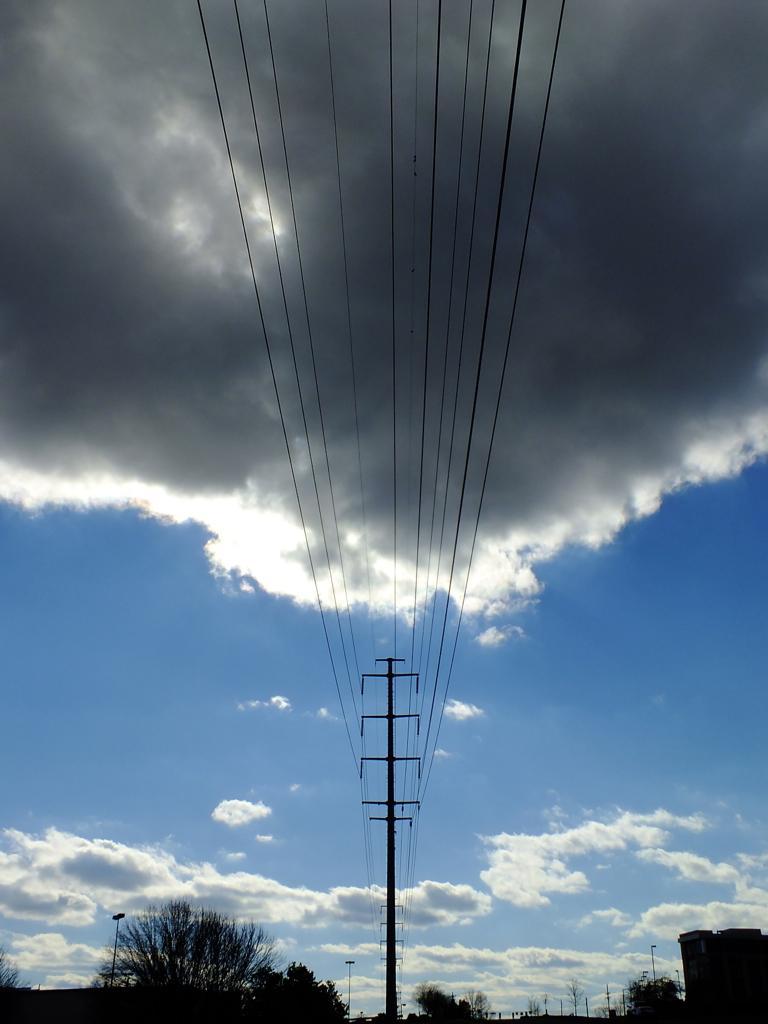Could you give a brief overview of what you see in this image? In this image there are poles connected with wires. Bottom of the image there are trees and buildings. Background there is sky with some clouds. 